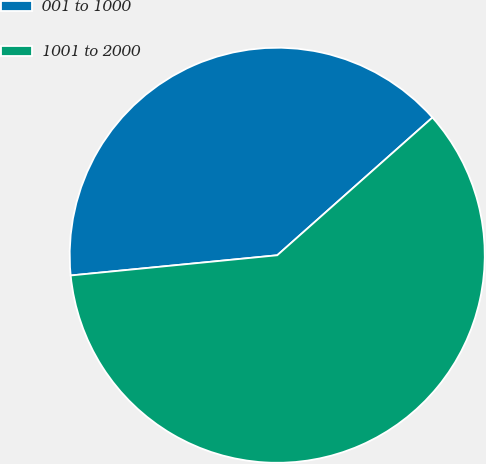<chart> <loc_0><loc_0><loc_500><loc_500><pie_chart><fcel>001 to 1000<fcel>1001 to 2000<nl><fcel>40.0%<fcel>60.0%<nl></chart> 